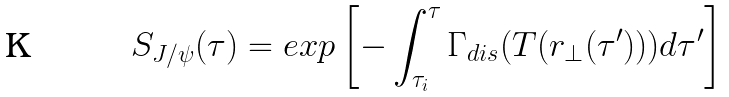<formula> <loc_0><loc_0><loc_500><loc_500>S _ { J / \psi } ( \tau ) = e x p \left [ - \int _ { \tau _ { i } } ^ { \tau } \Gamma _ { d i s } ( T ( { r } _ { \perp } ( \tau ^ { \prime } ) ) ) d \tau ^ { \prime } \right ]</formula> 